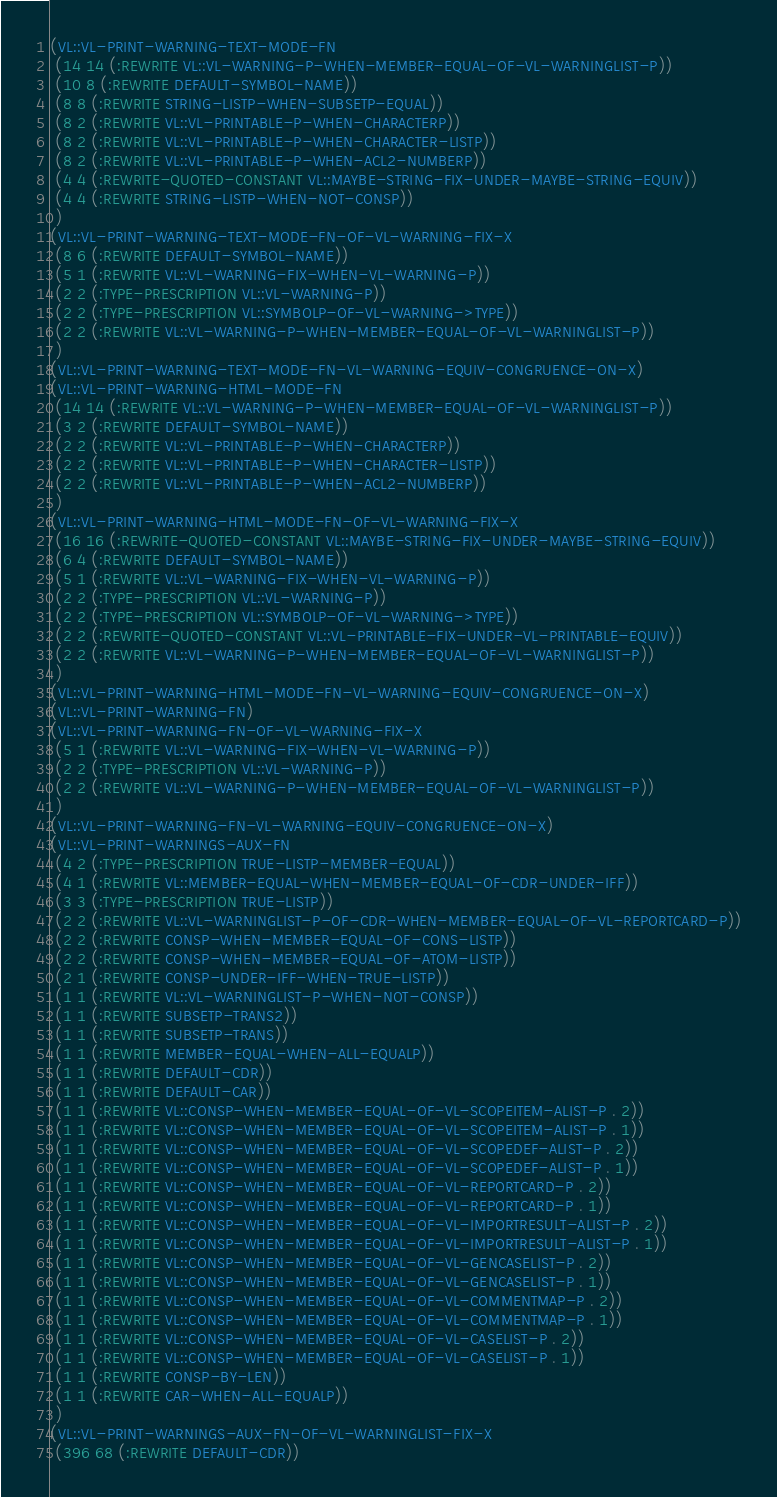Convert code to text. <code><loc_0><loc_0><loc_500><loc_500><_Lisp_>(VL::VL-PRINT-WARNING-TEXT-MODE-FN
 (14 14 (:REWRITE VL::VL-WARNING-P-WHEN-MEMBER-EQUAL-OF-VL-WARNINGLIST-P))
 (10 8 (:REWRITE DEFAULT-SYMBOL-NAME))
 (8 8 (:REWRITE STRING-LISTP-WHEN-SUBSETP-EQUAL))
 (8 2 (:REWRITE VL::VL-PRINTABLE-P-WHEN-CHARACTERP))
 (8 2 (:REWRITE VL::VL-PRINTABLE-P-WHEN-CHARACTER-LISTP))
 (8 2 (:REWRITE VL::VL-PRINTABLE-P-WHEN-ACL2-NUMBERP))
 (4 4 (:REWRITE-QUOTED-CONSTANT VL::MAYBE-STRING-FIX-UNDER-MAYBE-STRING-EQUIV))
 (4 4 (:REWRITE STRING-LISTP-WHEN-NOT-CONSP))
 )
(VL::VL-PRINT-WARNING-TEXT-MODE-FN-OF-VL-WARNING-FIX-X
 (8 6 (:REWRITE DEFAULT-SYMBOL-NAME))
 (5 1 (:REWRITE VL::VL-WARNING-FIX-WHEN-VL-WARNING-P))
 (2 2 (:TYPE-PRESCRIPTION VL::VL-WARNING-P))
 (2 2 (:TYPE-PRESCRIPTION VL::SYMBOLP-OF-VL-WARNING->TYPE))
 (2 2 (:REWRITE VL::VL-WARNING-P-WHEN-MEMBER-EQUAL-OF-VL-WARNINGLIST-P))
 )
(VL::VL-PRINT-WARNING-TEXT-MODE-FN-VL-WARNING-EQUIV-CONGRUENCE-ON-X)
(VL::VL-PRINT-WARNING-HTML-MODE-FN
 (14 14 (:REWRITE VL::VL-WARNING-P-WHEN-MEMBER-EQUAL-OF-VL-WARNINGLIST-P))
 (3 2 (:REWRITE DEFAULT-SYMBOL-NAME))
 (2 2 (:REWRITE VL::VL-PRINTABLE-P-WHEN-CHARACTERP))
 (2 2 (:REWRITE VL::VL-PRINTABLE-P-WHEN-CHARACTER-LISTP))
 (2 2 (:REWRITE VL::VL-PRINTABLE-P-WHEN-ACL2-NUMBERP))
 )
(VL::VL-PRINT-WARNING-HTML-MODE-FN-OF-VL-WARNING-FIX-X
 (16 16 (:REWRITE-QUOTED-CONSTANT VL::MAYBE-STRING-FIX-UNDER-MAYBE-STRING-EQUIV))
 (6 4 (:REWRITE DEFAULT-SYMBOL-NAME))
 (5 1 (:REWRITE VL::VL-WARNING-FIX-WHEN-VL-WARNING-P))
 (2 2 (:TYPE-PRESCRIPTION VL::VL-WARNING-P))
 (2 2 (:TYPE-PRESCRIPTION VL::SYMBOLP-OF-VL-WARNING->TYPE))
 (2 2 (:REWRITE-QUOTED-CONSTANT VL::VL-PRINTABLE-FIX-UNDER-VL-PRINTABLE-EQUIV))
 (2 2 (:REWRITE VL::VL-WARNING-P-WHEN-MEMBER-EQUAL-OF-VL-WARNINGLIST-P))
 )
(VL::VL-PRINT-WARNING-HTML-MODE-FN-VL-WARNING-EQUIV-CONGRUENCE-ON-X)
(VL::VL-PRINT-WARNING-FN)
(VL::VL-PRINT-WARNING-FN-OF-VL-WARNING-FIX-X
 (5 1 (:REWRITE VL::VL-WARNING-FIX-WHEN-VL-WARNING-P))
 (2 2 (:TYPE-PRESCRIPTION VL::VL-WARNING-P))
 (2 2 (:REWRITE VL::VL-WARNING-P-WHEN-MEMBER-EQUAL-OF-VL-WARNINGLIST-P))
 )
(VL::VL-PRINT-WARNING-FN-VL-WARNING-EQUIV-CONGRUENCE-ON-X)
(VL::VL-PRINT-WARNINGS-AUX-FN
 (4 2 (:TYPE-PRESCRIPTION TRUE-LISTP-MEMBER-EQUAL))
 (4 1 (:REWRITE VL::MEMBER-EQUAL-WHEN-MEMBER-EQUAL-OF-CDR-UNDER-IFF))
 (3 3 (:TYPE-PRESCRIPTION TRUE-LISTP))
 (2 2 (:REWRITE VL::VL-WARNINGLIST-P-OF-CDR-WHEN-MEMBER-EQUAL-OF-VL-REPORTCARD-P))
 (2 2 (:REWRITE CONSP-WHEN-MEMBER-EQUAL-OF-CONS-LISTP))
 (2 2 (:REWRITE CONSP-WHEN-MEMBER-EQUAL-OF-ATOM-LISTP))
 (2 1 (:REWRITE CONSP-UNDER-IFF-WHEN-TRUE-LISTP))
 (1 1 (:REWRITE VL::VL-WARNINGLIST-P-WHEN-NOT-CONSP))
 (1 1 (:REWRITE SUBSETP-TRANS2))
 (1 1 (:REWRITE SUBSETP-TRANS))
 (1 1 (:REWRITE MEMBER-EQUAL-WHEN-ALL-EQUALP))
 (1 1 (:REWRITE DEFAULT-CDR))
 (1 1 (:REWRITE DEFAULT-CAR))
 (1 1 (:REWRITE VL::CONSP-WHEN-MEMBER-EQUAL-OF-VL-SCOPEITEM-ALIST-P . 2))
 (1 1 (:REWRITE VL::CONSP-WHEN-MEMBER-EQUAL-OF-VL-SCOPEITEM-ALIST-P . 1))
 (1 1 (:REWRITE VL::CONSP-WHEN-MEMBER-EQUAL-OF-VL-SCOPEDEF-ALIST-P . 2))
 (1 1 (:REWRITE VL::CONSP-WHEN-MEMBER-EQUAL-OF-VL-SCOPEDEF-ALIST-P . 1))
 (1 1 (:REWRITE VL::CONSP-WHEN-MEMBER-EQUAL-OF-VL-REPORTCARD-P . 2))
 (1 1 (:REWRITE VL::CONSP-WHEN-MEMBER-EQUAL-OF-VL-REPORTCARD-P . 1))
 (1 1 (:REWRITE VL::CONSP-WHEN-MEMBER-EQUAL-OF-VL-IMPORTRESULT-ALIST-P . 2))
 (1 1 (:REWRITE VL::CONSP-WHEN-MEMBER-EQUAL-OF-VL-IMPORTRESULT-ALIST-P . 1))
 (1 1 (:REWRITE VL::CONSP-WHEN-MEMBER-EQUAL-OF-VL-GENCASELIST-P . 2))
 (1 1 (:REWRITE VL::CONSP-WHEN-MEMBER-EQUAL-OF-VL-GENCASELIST-P . 1))
 (1 1 (:REWRITE VL::CONSP-WHEN-MEMBER-EQUAL-OF-VL-COMMENTMAP-P . 2))
 (1 1 (:REWRITE VL::CONSP-WHEN-MEMBER-EQUAL-OF-VL-COMMENTMAP-P . 1))
 (1 1 (:REWRITE VL::CONSP-WHEN-MEMBER-EQUAL-OF-VL-CASELIST-P . 2))
 (1 1 (:REWRITE VL::CONSP-WHEN-MEMBER-EQUAL-OF-VL-CASELIST-P . 1))
 (1 1 (:REWRITE CONSP-BY-LEN))
 (1 1 (:REWRITE CAR-WHEN-ALL-EQUALP))
 )
(VL::VL-PRINT-WARNINGS-AUX-FN-OF-VL-WARNINGLIST-FIX-X
 (396 68 (:REWRITE DEFAULT-CDR))</code> 